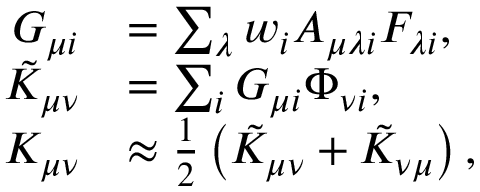Convert formula to latex. <formula><loc_0><loc_0><loc_500><loc_500>\begin{array} { r l } { G _ { \mu i } } & { = \sum _ { \lambda } w _ { i } A _ { \mu \lambda i } F _ { \lambda i } , } \\ { \tilde { K } _ { \mu \nu } } & { = \sum _ { i } G _ { \mu i } \Phi _ { \nu i } , } \\ { K _ { \mu \nu } } & { \approx \frac { 1 } { 2 } \left ( \tilde { K } _ { \mu \nu } + \tilde { K } _ { \nu \mu } \right ) , } \end{array}</formula> 